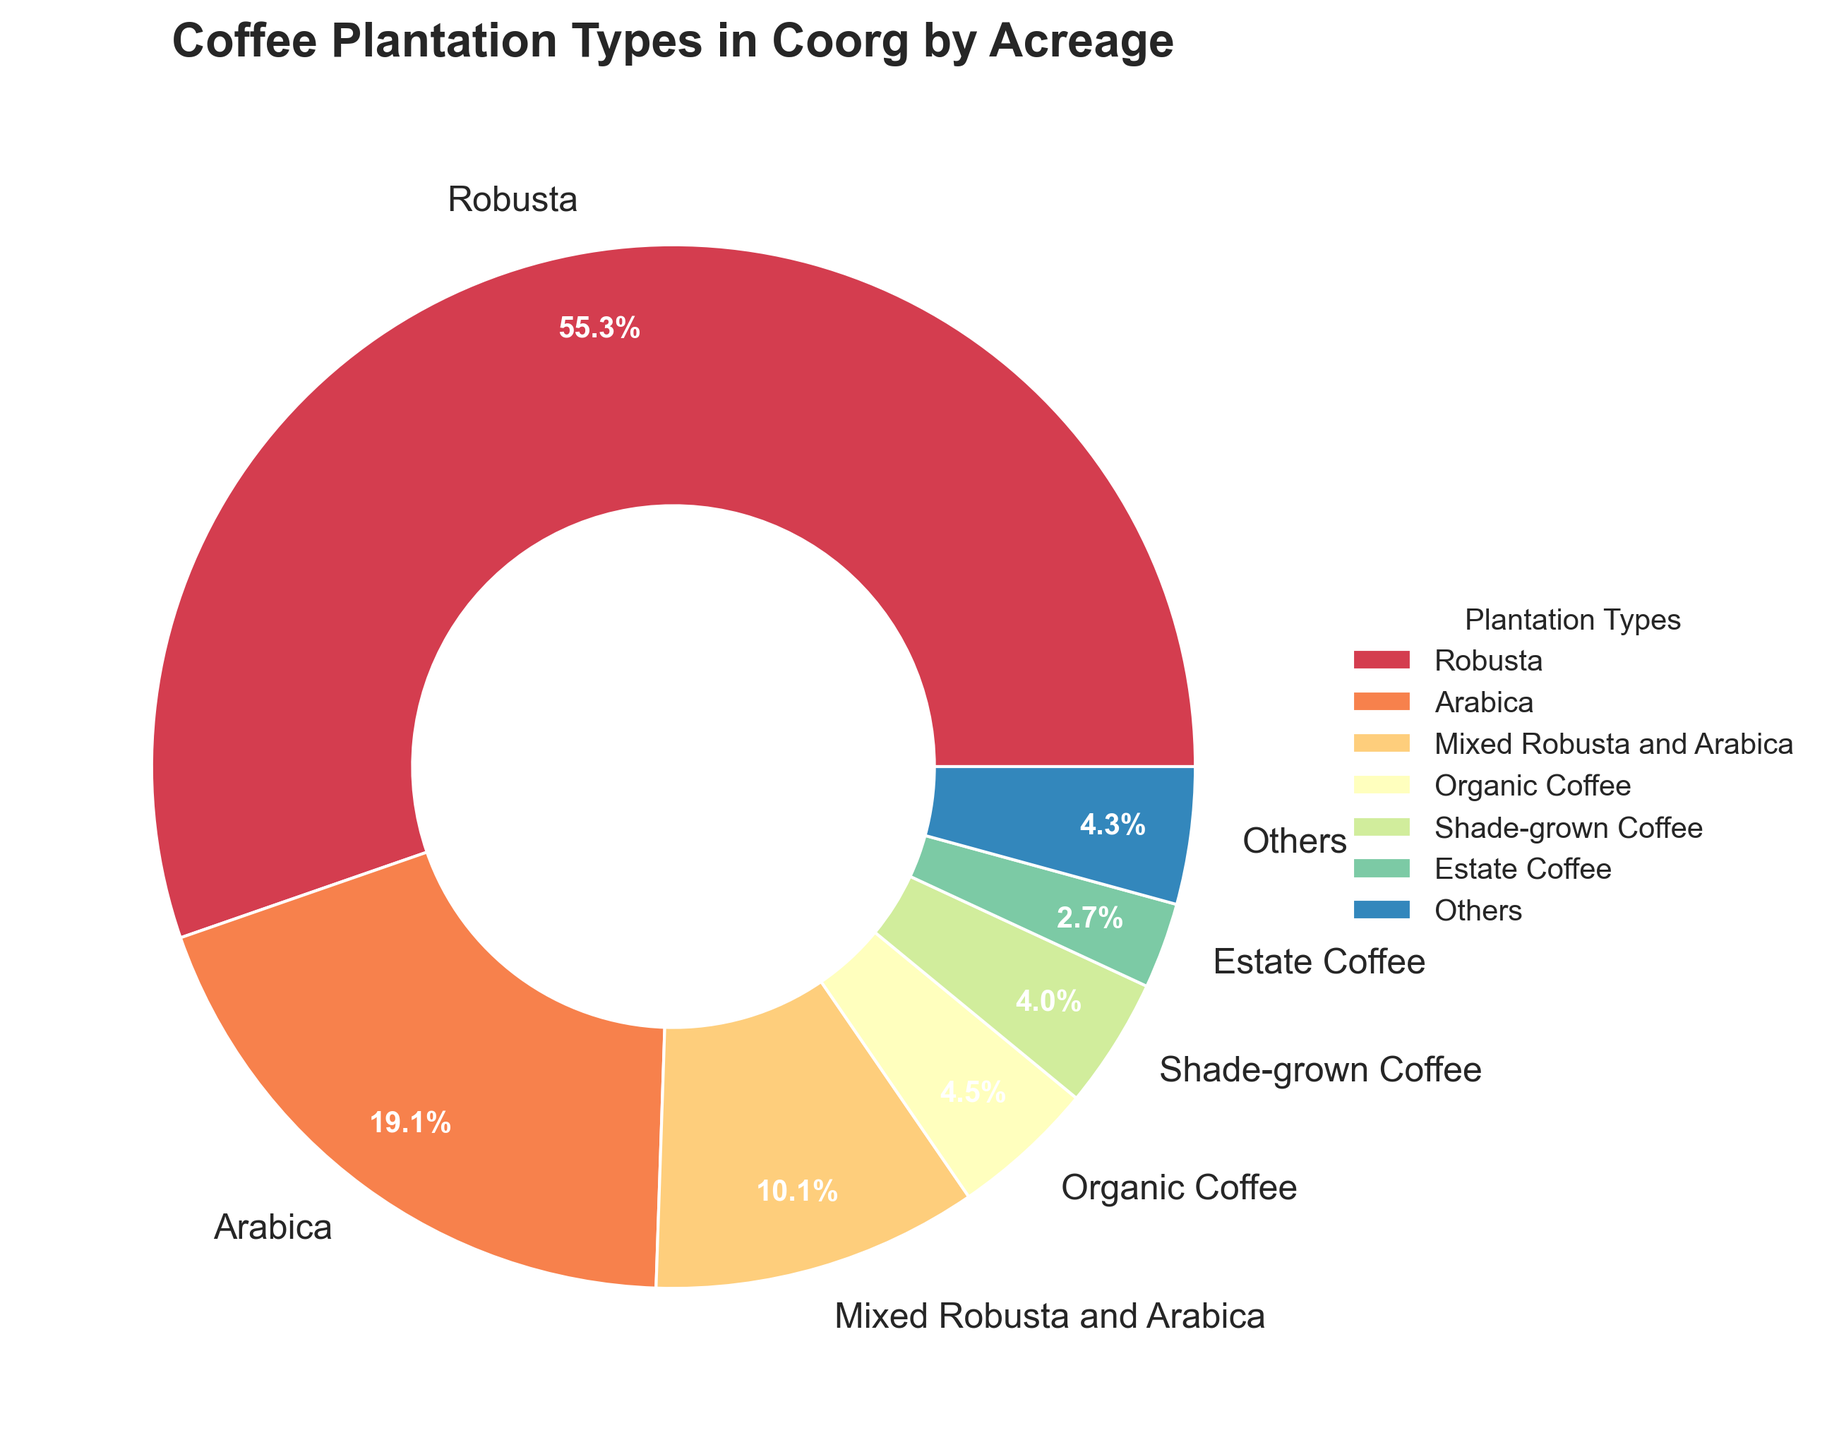What percentage of the total coffee acreage is occupied by Robusta coffee? First, identify the acreage for Robusta coffee, which is 52,000 acres. Next, note that the pie chart provides the percentage directly for each category. The label for Robusta coffee shows approximately 58.8%.
Answer: 58.8% What is the combined acreage of Organic Coffee and Shade-grown Coffee? First, find the acreage for Organic Coffee and Shade-grown Coffee, which are 4,200 and 3,800 acres respectively. Sum these values: 4,200 + 3,800 = 8,000 acres.
Answer: 8,000 acres Which type of coffee plantation covers the smallest area according to the pie chart? By observing the pie chart, identify the section with the smallest slice, which represents a coverage of about 0.1%. The label indicates this is the Experimental Varieties area.
Answer: Experimental Varieties What is the difference in acreage between Arabica and Mixed Robusta and Arabica plantations? Identify the acreage for Arabica (18,000 acres) and Mixed Robusta and Arabica (9,500 acres). Calculate the difference: 18,000 - 9,500 = 8,500 acres.
Answer: 8,500 acres Which coffee plantation type has approximately half the acreage of Arabica coffee? First, note the acreage for Arabica coffee is 18,000 acres. Half of this area is 18,000 / 2 = 9,000 acres. Observe that Mixed Robusta and Arabica coffee has 9,500 acres, which is closest to half of Arabica’s acreage.
Answer: Mixed Robusta and Arabica How many types of coffee plantations cover less than 5% of the total acreage? By observing the pie chart, note the sections labeled with percentages. Experimental Varieties, Coffee-Cardamom Intercrop, and Coffee-Pepper Intercrop each cover less than 5%. This totals to three types.
Answer: Three Which coffee plantation type uses a yellow shade in the pie chart? Observe the color-coding in the pie chart. The section labeled with the yellow segment represents Organic Coffee.
Answer: Organic Coffee What is the total acreage represented by the 'Others' category in the pie chart? Note that the 'Others' category, which combines smaller categories, is directly labeled in the pie chart and encompasses 5.4%. This combined value is 6,500 acres (sum of Estate Coffee, Small-holder Plantations, Coffee-Pepper Intercrop, Coffee-Cardamom Intercrop, Experimental Varieties).
Answer: 6,500 acres Which type of coffee plantation is represented by the largest slice in the pie chart? Observe the largest slice in the pie chart, which is clearly marked with 58.8%. The label indicates this slice represents Robusta coffee.
Answer: Robusta 